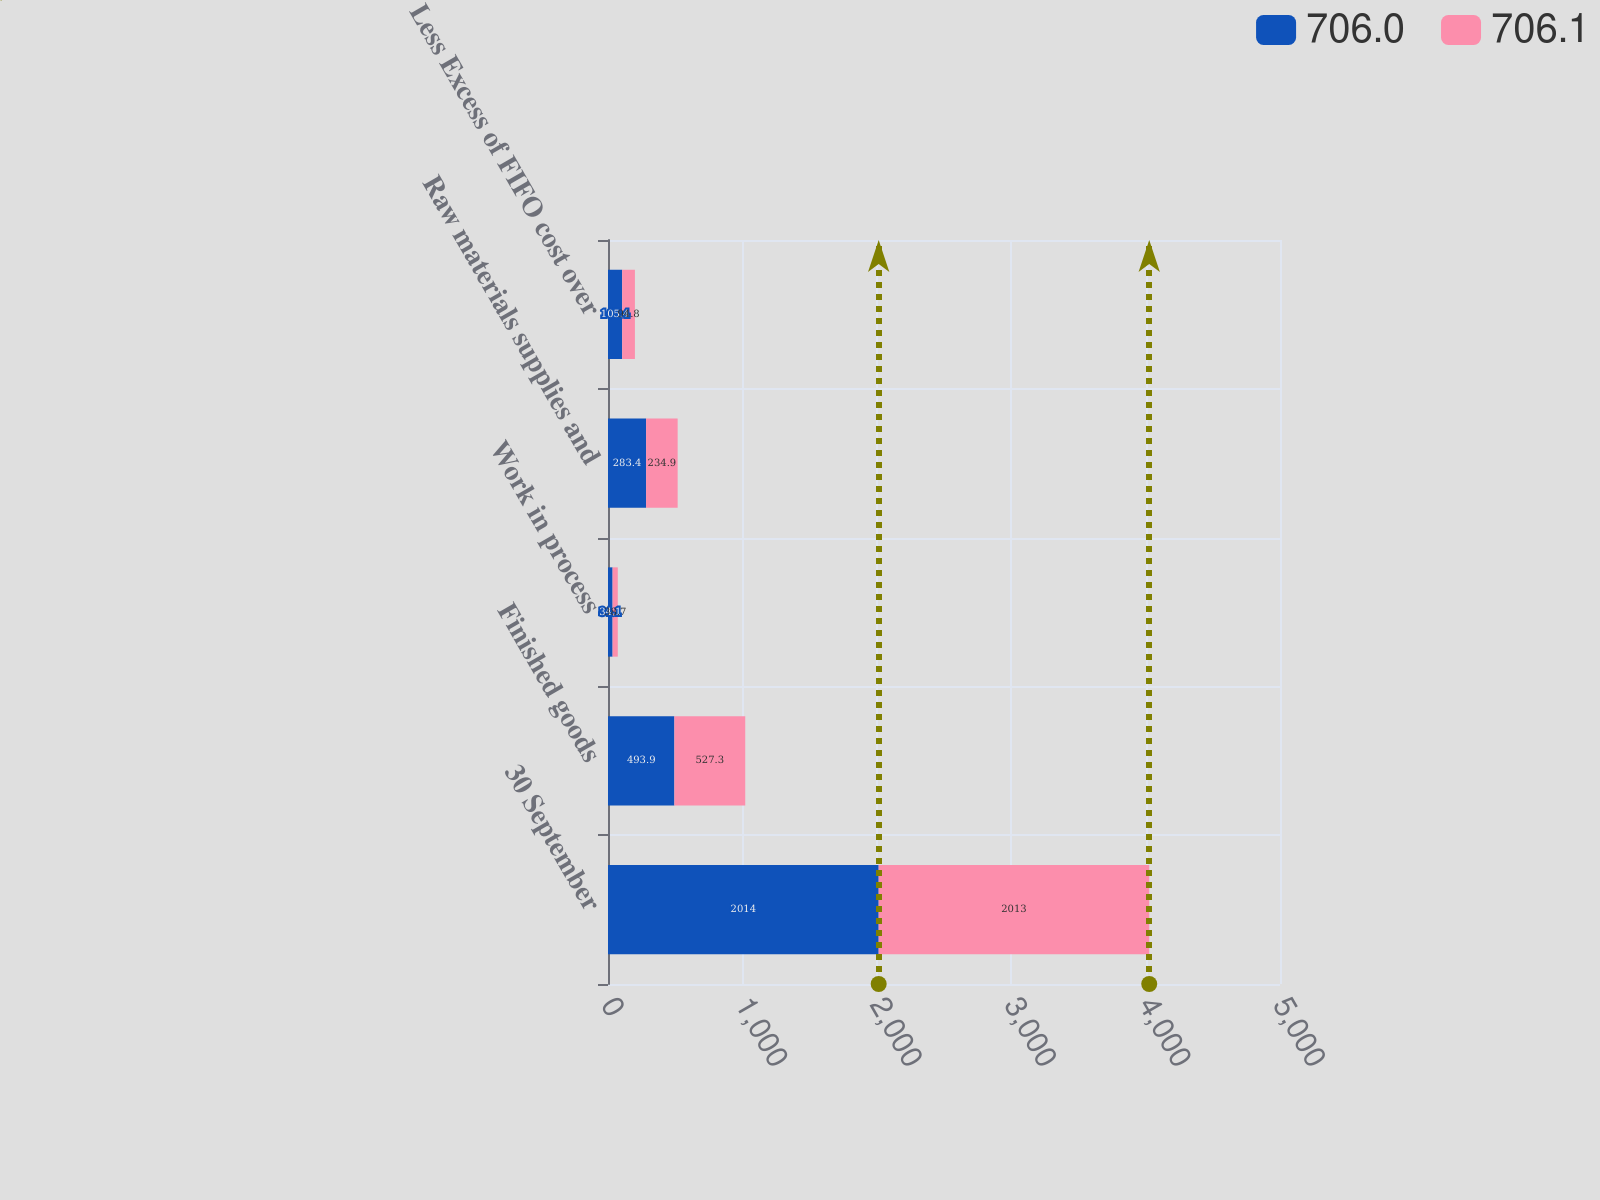Convert chart. <chart><loc_0><loc_0><loc_500><loc_500><stacked_bar_chart><ecel><fcel>30 September<fcel>Finished goods<fcel>Work in process<fcel>Raw materials supplies and<fcel>Less Excess of FIFO cost over<nl><fcel>706<fcel>2014<fcel>493.9<fcel>34.1<fcel>283.4<fcel>105.4<nl><fcel>706.1<fcel>2013<fcel>527.3<fcel>38.7<fcel>234.9<fcel>94.8<nl></chart> 